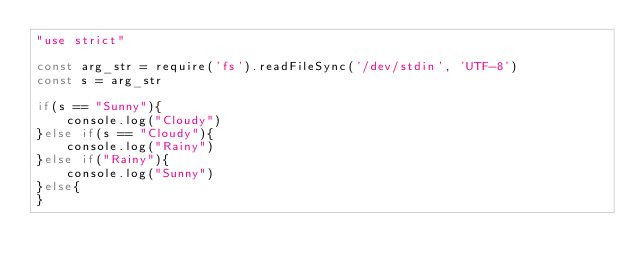<code> <loc_0><loc_0><loc_500><loc_500><_JavaScript_>"use strict"
 
const arg_str = require('fs').readFileSync('/dev/stdin', 'UTF-8')
const s = arg_str
 
if(s == "Sunny"){
    console.log("Cloudy")
}else if(s == "Cloudy"){
    console.log("Rainy")
}else if("Rainy"){
    console.log("Sunny")
}else{
}</code> 